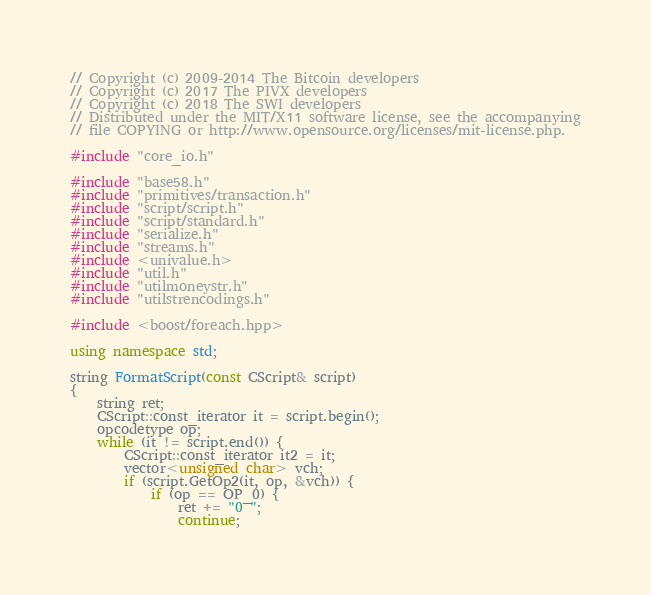<code> <loc_0><loc_0><loc_500><loc_500><_C++_>// Copyright (c) 2009-2014 The Bitcoin developers
// Copyright (c) 2017 The PIVX developers
// Copyright (c) 2018 The SWI developers
// Distributed under the MIT/X11 software license, see the accompanying
// file COPYING or http://www.opensource.org/licenses/mit-license.php.

#include "core_io.h"

#include "base58.h"
#include "primitives/transaction.h"
#include "script/script.h"
#include "script/standard.h"
#include "serialize.h"
#include "streams.h"
#include <univalue.h>
#include "util.h"
#include "utilmoneystr.h"
#include "utilstrencodings.h"

#include <boost/foreach.hpp>

using namespace std;

string FormatScript(const CScript& script)
{
    string ret;
    CScript::const_iterator it = script.begin();
    opcodetype op;
    while (it != script.end()) {
        CScript::const_iterator it2 = it;
        vector<unsigned char> vch;
        if (script.GetOp2(it, op, &vch)) {
            if (op == OP_0) {
                ret += "0 ";
                continue;</code> 